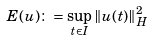<formula> <loc_0><loc_0><loc_500><loc_500>E ( u ) \colon = \sup _ { t \in I } \| u ( t ) \| _ { H } ^ { 2 }</formula> 